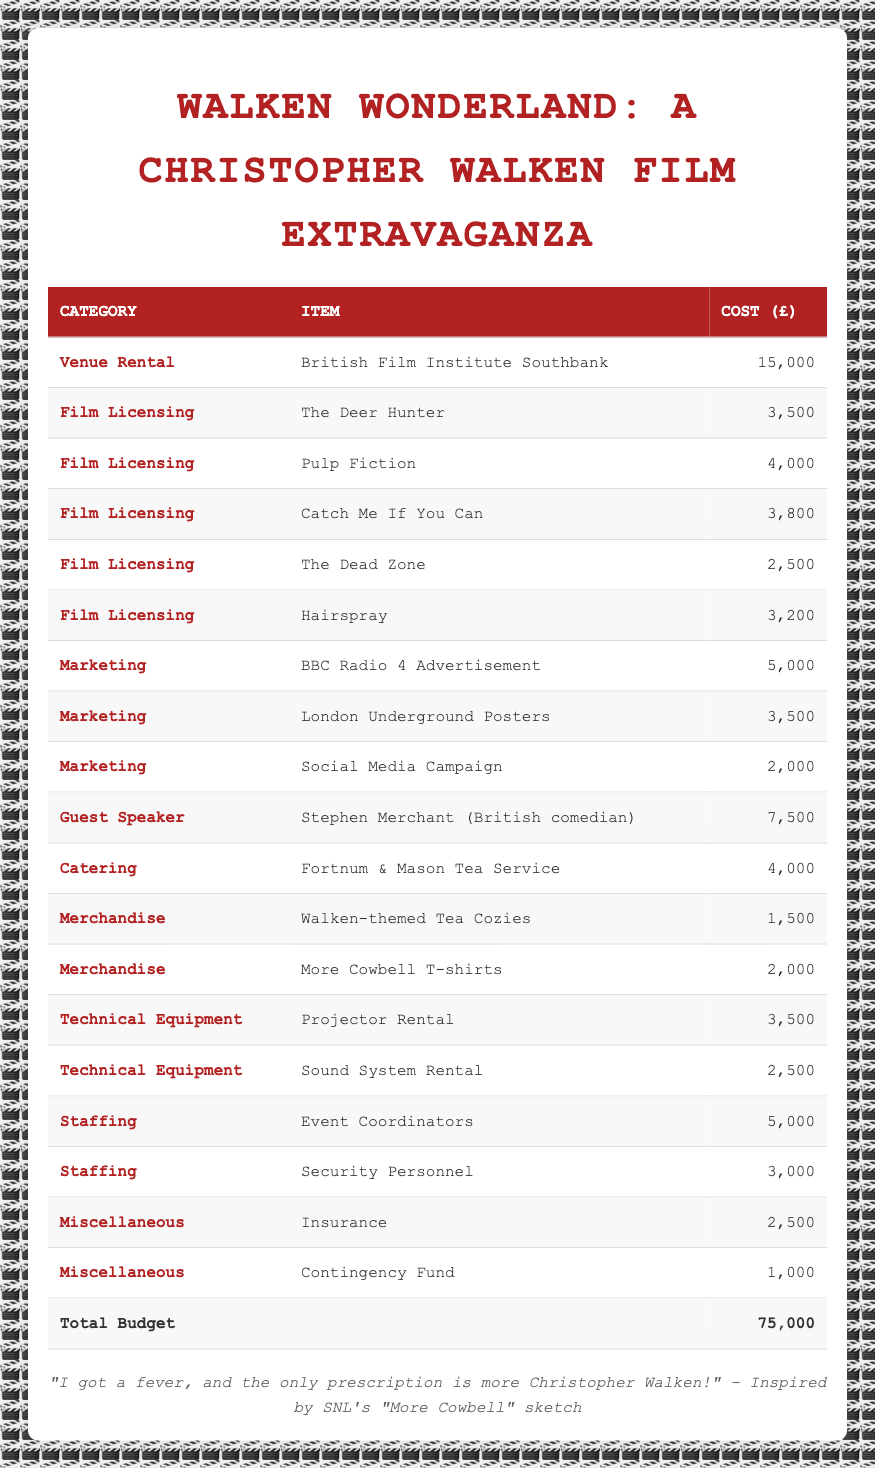What is the total budget for the festival? The total budget is explicitly listed at the bottom of the table in the 'Total Budget' row, which shows a cost of 75,000.
Answer: 75,000 How much was spent on licensing the film "Pulp Fiction"? The cost for licensing "Pulp Fiction" is directly mentioned in the table under the Film Licensing category, which is 4,000.
Answer: 4,000 What is the combined cost of all the film licensing fees? To find the total cost of film licensing, sum the individual costs: 3,500 (The Deer Hunter) + 4,000 (Pulp Fiction) + 3,800 (Catch Me If You Can) + 2,500 (The Dead Zone) + 3,200 (Hairspray) = 17,000.
Answer: 17,000 Is the cost for the BBC Radio 4 Advertisement higher than the cost for the Social Media Campaign? The cost for the BBC Radio 4 Advertisement is listed as 5,000, while the Social Media Campaign costs 2,000. Since 5,000 is greater than 2,000, the answer is yes.
Answer: Yes What percentage of the total budget is allocated to the Guest Speaker fee for Stephen Merchant? The cost for the Guest Speaker is 7,500. To find the percentage of the total budget, divide the Guest Speaker fee by the total budget and multiply by 100: (7,500 / 75,000) * 100 = 10%.
Answer: 10% What is the total expenditure on marketing? Add the costs for all marketing items: 5,000 (BBC Radio 4 Advertisement) + 3,500 (London Underground Posters) + 2,000 (Social Media Campaign) = 10,500.
Answer: 10,500 Which item has the highest cost in the budget breakdown? Reviewing the table, the Guest Speaker fee for Stephen Merchant at 7,500 is the highest individual cost listed among all categories.
Answer: Stephen Merchant (7,500) How much did the festival spend on merchandise? The total merchandise costs are from two items: 1,500 (Walken-themed Tea Cozies) + 2,000 (More Cowbell T-shirts) = 3,500.
Answer: 3,500 Was the cost of the Fortnum & Mason Tea Service higher than the cost for the Security Personnel? The cost for Fortnum & Mason Tea Service is 4,000, while the Security Personnel cost is 3,000. Since 4,000 is greater than 3,000, the answer is yes.
Answer: Yes 